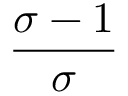Convert formula to latex. <formula><loc_0><loc_0><loc_500><loc_500>\frac { \sigma - 1 } { \sigma }</formula> 